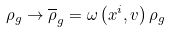<formula> <loc_0><loc_0><loc_500><loc_500>\rho _ { g } \rightarrow \overline { \rho } _ { g } = \omega \left ( x ^ { i } , v \right ) \rho _ { g }</formula> 